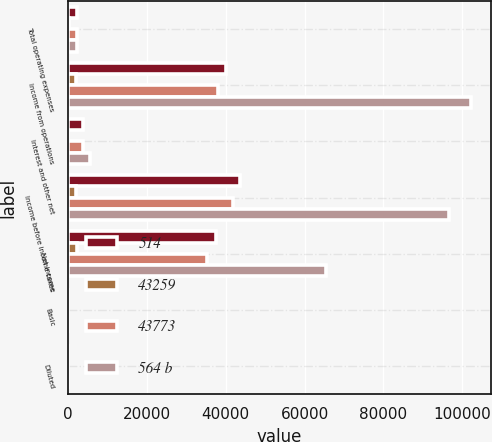<chart> <loc_0><loc_0><loc_500><loc_500><stacked_bar_chart><ecel><fcel>Total operating expenses<fcel>Income from operations<fcel>Interest and other net<fcel>Income before income taxes<fcel>Net income<fcel>Basic<fcel>Diluted<nl><fcel>514<fcel>2161<fcel>39981<fcel>3715<fcel>43696<fcel>37475<fcel>0.54<fcel>0.53<nl><fcel>43259<fcel>208<fcel>1963<fcel>13<fcel>1976<fcel>2161<fcel>0.03<fcel>0.03<nl><fcel>43773<fcel>2161<fcel>38018<fcel>3702<fcel>41720<fcel>35314<fcel>0.51<fcel>0.5<nl><fcel>564 b<fcel>2161<fcel>102134<fcel>5524<fcel>96610<fcel>65378<fcel>0.97<fcel>0.95<nl></chart> 